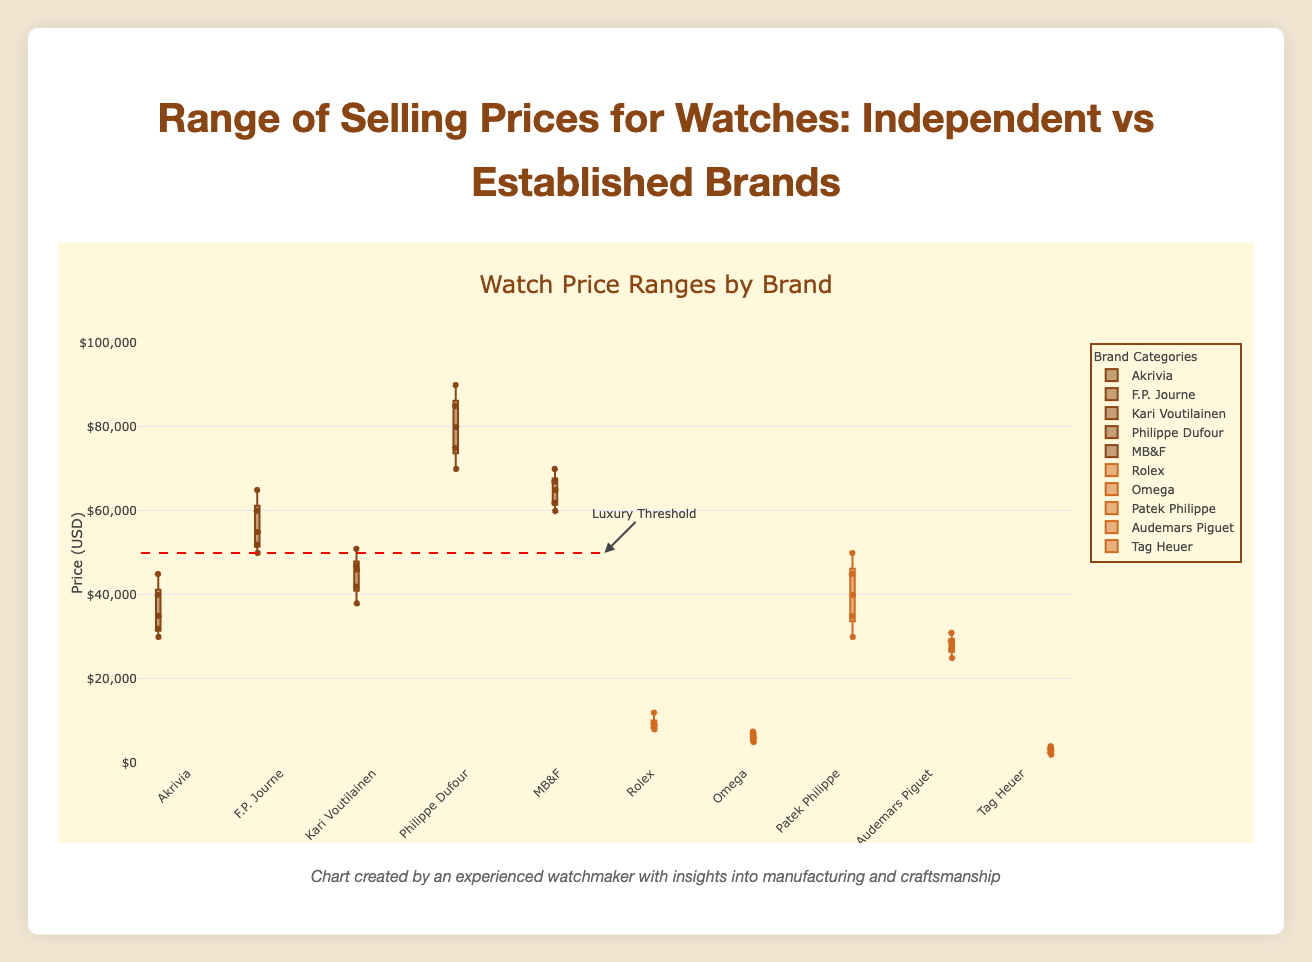What is the price range of watches for the brand "Rolex"? The price range can be determined by identifying the minimum and maximum values for Rolex. The prices are [8000, 9000, 8500, 9500, 12000], so the range is 8000 to 12000 USD.
Answer: 8000 to 12000 USD Which brand among the established brands has the lowest median selling price? To identify the brand with the lowest median, we should look at the middle value of each brand's price list. Tag Heuer's prices are [2000, 2500, 3000, 3500, 4000], with a median of 3000 USD, which is the lowest among the established brands.
Answer: Tag Heuer What is the interquartile range (IQR) for "Akrivia"? The IQR is calculated by subtracting the first quartile (Q1) from the third quartile (Q3). Akrivia's prices are [30000, 32000, 35000, 40000, 45000]. Here, Q1 = 32000 and Q3 = 40000, so IQR = 40000 - 32000 = 8000 USD.
Answer: 8000 USD Which brand has the highest maximum selling price amongst all brands? From the data, Philippe Dufour has the highest maximum price of 90000 USD. This is higher than the maximum prices of other brands.
Answer: Philippe Dufour How does the price range of "Patek Philippe" compare to "Audemars Piguet"? Patek Philippe has a price range from 30000 to 50000 USD, while Audemars Piguet ranges from 25000 to 31000 USD. Patek Philippe's range is wider and higher in values.
Answer: Patek Philippe's range is wider and higher What is the median price for "Kari Voutilainen"? The prices are [38000, 42000, 46000, 47000, 51000]. The median value is the middle value, which is 46000 USD.
Answer: 46000 USD Which independent brand has the smallest interquartile range? The smallest interquartile range is determined by calculating the IQR for each independent brand. Calculating for each, we find that "Kari Voutilainen" with IQR = 47000 - 42000 = 5000 USD has the smallest IQR.
Answer: Kari Voutilainen Which established brand has the largest range of selling prices? The range is given by the difference between the maximum and the minimum values. Rolex has the prices [8000, 9000, 8500, 9500, 12000] with a range of 12000 - 8000 = 4000 USD, which is the largest among the established brands.
Answer: Rolex Is there any brand that falls entirely above the "Luxury Threshold" line drawn at 50000 USD? To determine this, identify if the minimum value for any brand is above 50000 USD. Philippe Dufour has prices [70000, 75000, 80000, 85000, 90000], all of which are above 50000 USD.
Answer: Philippe Dufour 